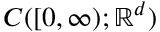Convert formula to latex. <formula><loc_0><loc_0><loc_500><loc_500>C ( [ 0 , \infty ) ; \mathbb { R } ^ { d } )</formula> 